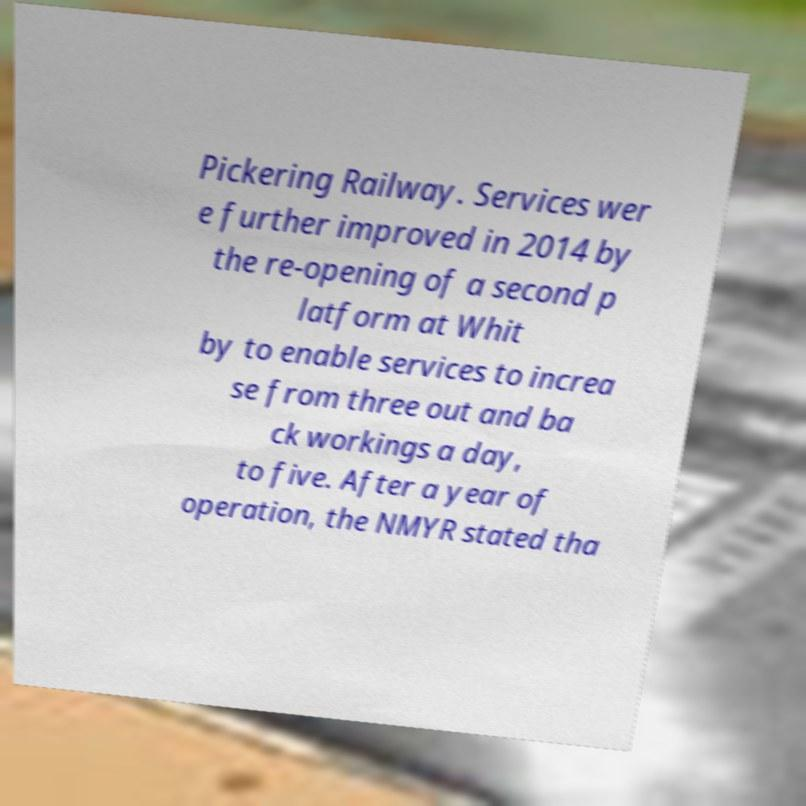Please read and relay the text visible in this image. What does it say? Pickering Railway. Services wer e further improved in 2014 by the re-opening of a second p latform at Whit by to enable services to increa se from three out and ba ck workings a day, to five. After a year of operation, the NMYR stated tha 